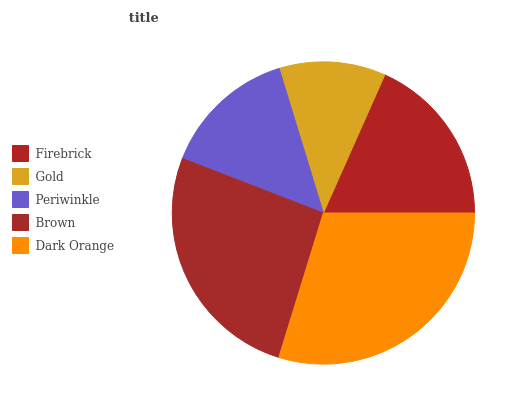Is Gold the minimum?
Answer yes or no. Yes. Is Dark Orange the maximum?
Answer yes or no. Yes. Is Periwinkle the minimum?
Answer yes or no. No. Is Periwinkle the maximum?
Answer yes or no. No. Is Periwinkle greater than Gold?
Answer yes or no. Yes. Is Gold less than Periwinkle?
Answer yes or no. Yes. Is Gold greater than Periwinkle?
Answer yes or no. No. Is Periwinkle less than Gold?
Answer yes or no. No. Is Firebrick the high median?
Answer yes or no. Yes. Is Firebrick the low median?
Answer yes or no. Yes. Is Gold the high median?
Answer yes or no. No. Is Periwinkle the low median?
Answer yes or no. No. 